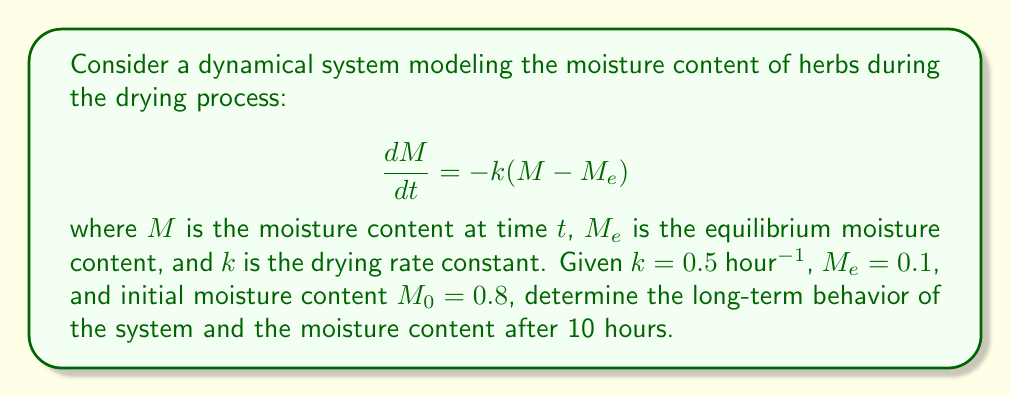Can you solve this math problem? 1. The given differential equation represents a first-order linear system:
   $$\frac{dM}{dt} = -k(M - M_e)$$

2. The general solution for this type of equation is:
   $$M(t) = M_e + (M_0 - M_e)e^{-kt}$$

3. Substitute the given values: $k = 0.5$ hour$^{-1}$, $M_e = 0.1$, and $M_0 = 0.8$:
   $$M(t) = 0.1 + (0.8 - 0.1)e^{-0.5t}$$
   $$M(t) = 0.1 + 0.7e^{-0.5t}$$

4. To determine the long-term behavior, take the limit as $t$ approaches infinity:
   $$\lim_{t \to \infty} M(t) = \lim_{t \to \infty} (0.1 + 0.7e^{-0.5t}) = 0.1$$

5. To find the moisture content after 10 hours, substitute $t = 10$ into the solution:
   $$M(10) = 0.1 + 0.7e^{-0.5(10)} \approx 0.1429$$

6. The system approaches the equilibrium moisture content $M_e = 0.1$ as $t \to \infty$, and the moisture content after 10 hours is approximately 0.1429.
Answer: Long-term behavior: $M \to 0.1$; Moisture content at $t = 10$ hours: $M(10) \approx 0.1429$ 